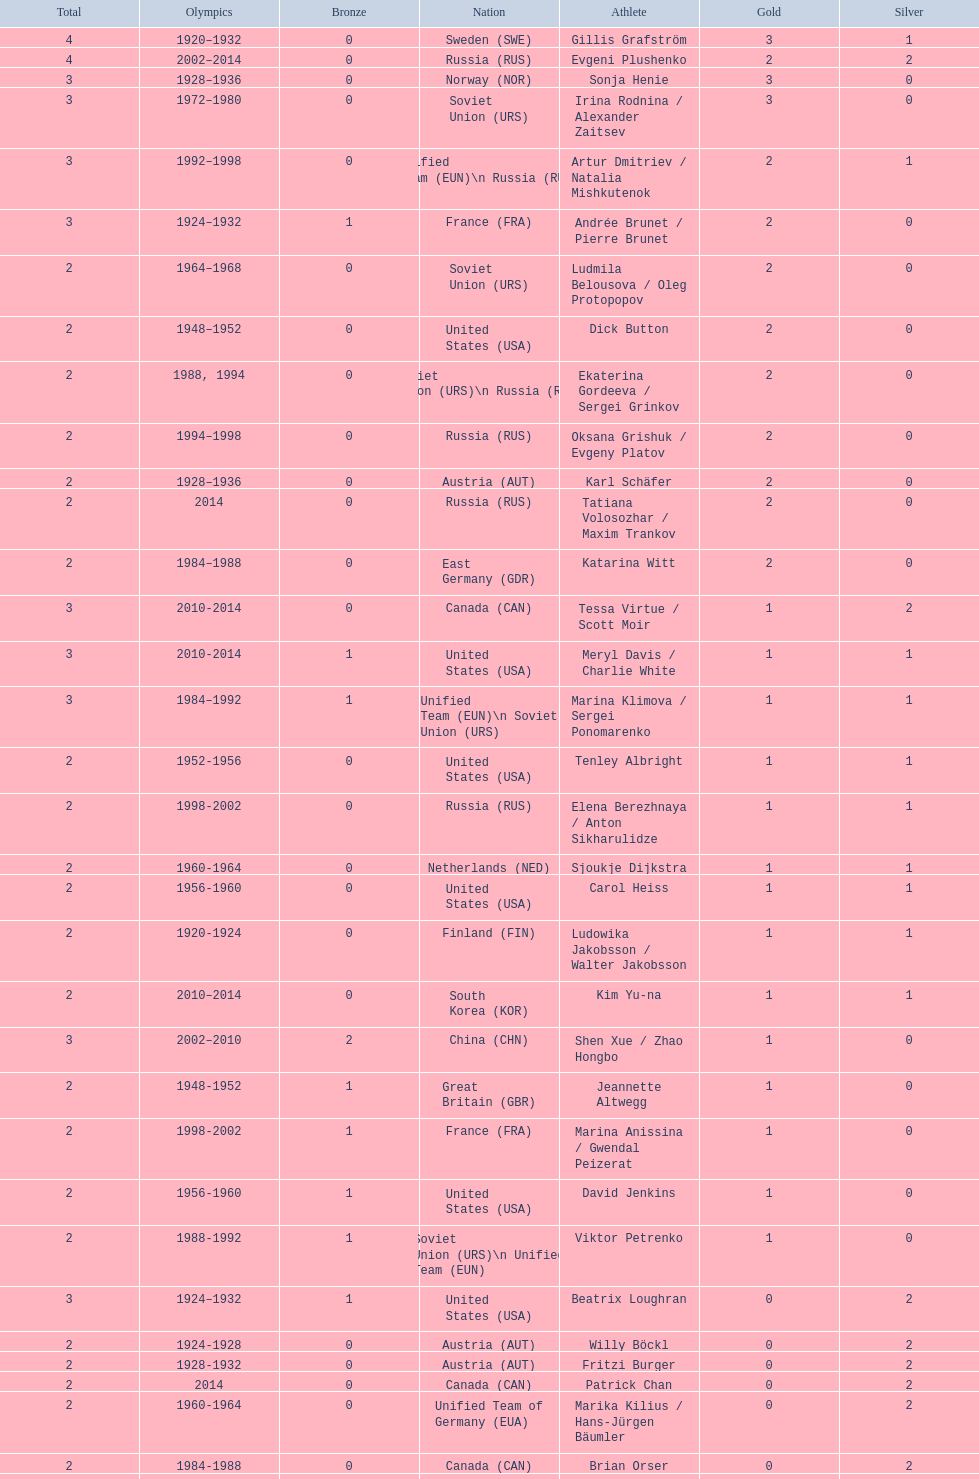How many total medals has the united states won in women's figure skating? 16. 